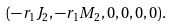<formula> <loc_0><loc_0><loc_500><loc_500>( - r _ { 1 } J _ { 2 } , - r _ { 1 } M _ { 2 } , 0 , 0 , 0 , 0 ) .</formula> 